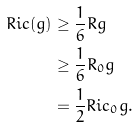Convert formula to latex. <formula><loc_0><loc_0><loc_500><loc_500>R i c ( g ) & \geq \frac { 1 } { 6 } R g \\ & \geq \frac { 1 } { 6 } R _ { 0 } g \\ & = \frac { 1 } { 2 } R i c _ { 0 } g .</formula> 